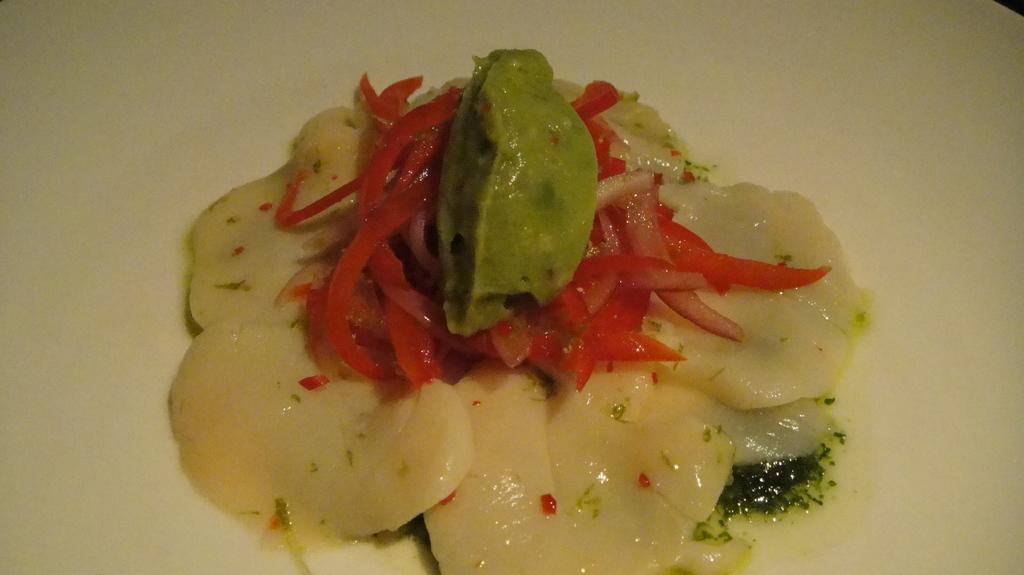What is the main subject of the image? There is a food item in the image. How is the food item presented in the image? The food item is served on a plate. What historical event is depicted in the image? There is no historical event depicted in the image; it features a food item served on a plate. What type of cheese is present in the image? There is no cheese present in the image. 